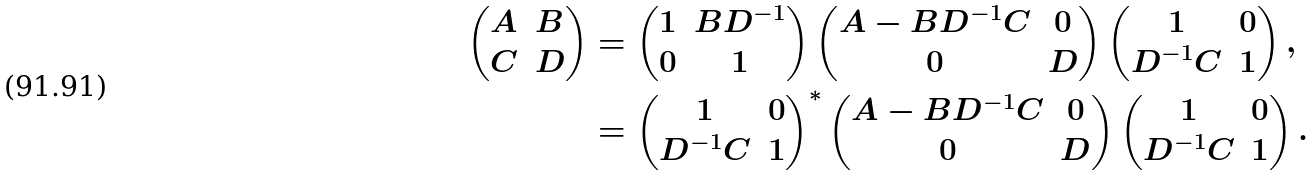<formula> <loc_0><loc_0><loc_500><loc_500>\begin{pmatrix} A & B \\ C & D \end{pmatrix} & = \begin{pmatrix} 1 & B D ^ { - 1 } \\ 0 & 1 \end{pmatrix} \begin{pmatrix} A - B D ^ { - 1 } C & 0 \\ 0 & D \end{pmatrix} \begin{pmatrix} 1 & 0 \\ D ^ { - 1 } C & 1 \end{pmatrix} , \\ & = \begin{pmatrix} 1 & 0 \\ D ^ { - 1 } C & 1 \end{pmatrix} ^ { * } \begin{pmatrix} A - B D ^ { - 1 } C & 0 \\ 0 & D \end{pmatrix} \begin{pmatrix} 1 & 0 \\ D ^ { - 1 } C & 1 \end{pmatrix} .</formula> 